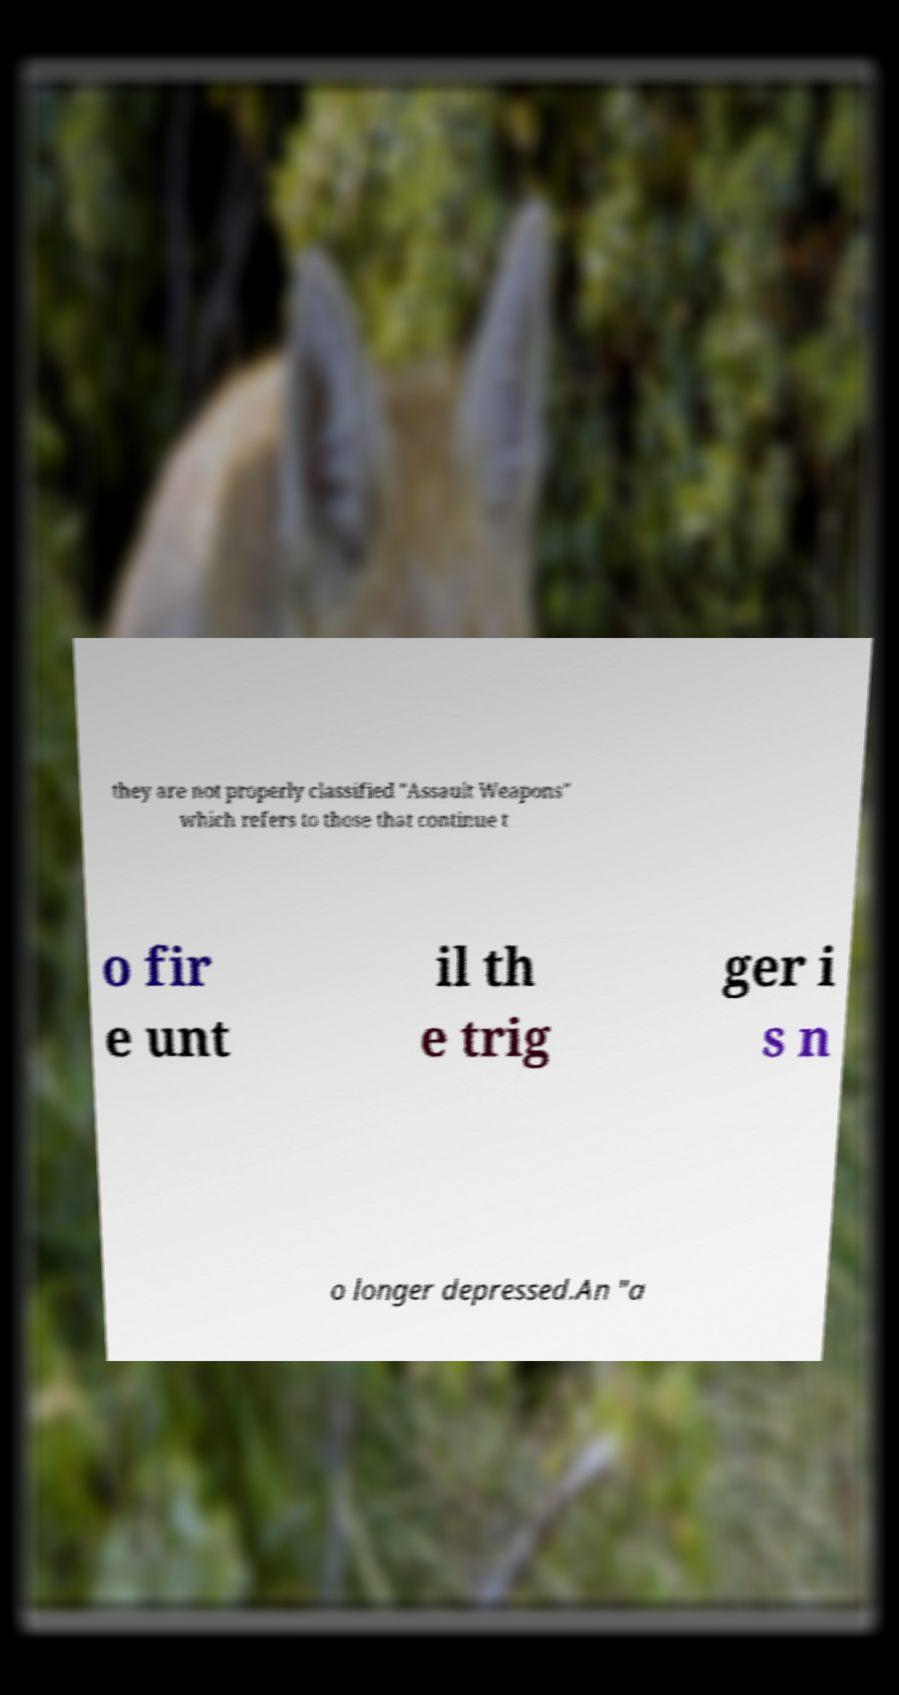Can you accurately transcribe the text from the provided image for me? they are not properly classified "Assault Weapons" which refers to those that continue t o fir e unt il th e trig ger i s n o longer depressed.An "a 